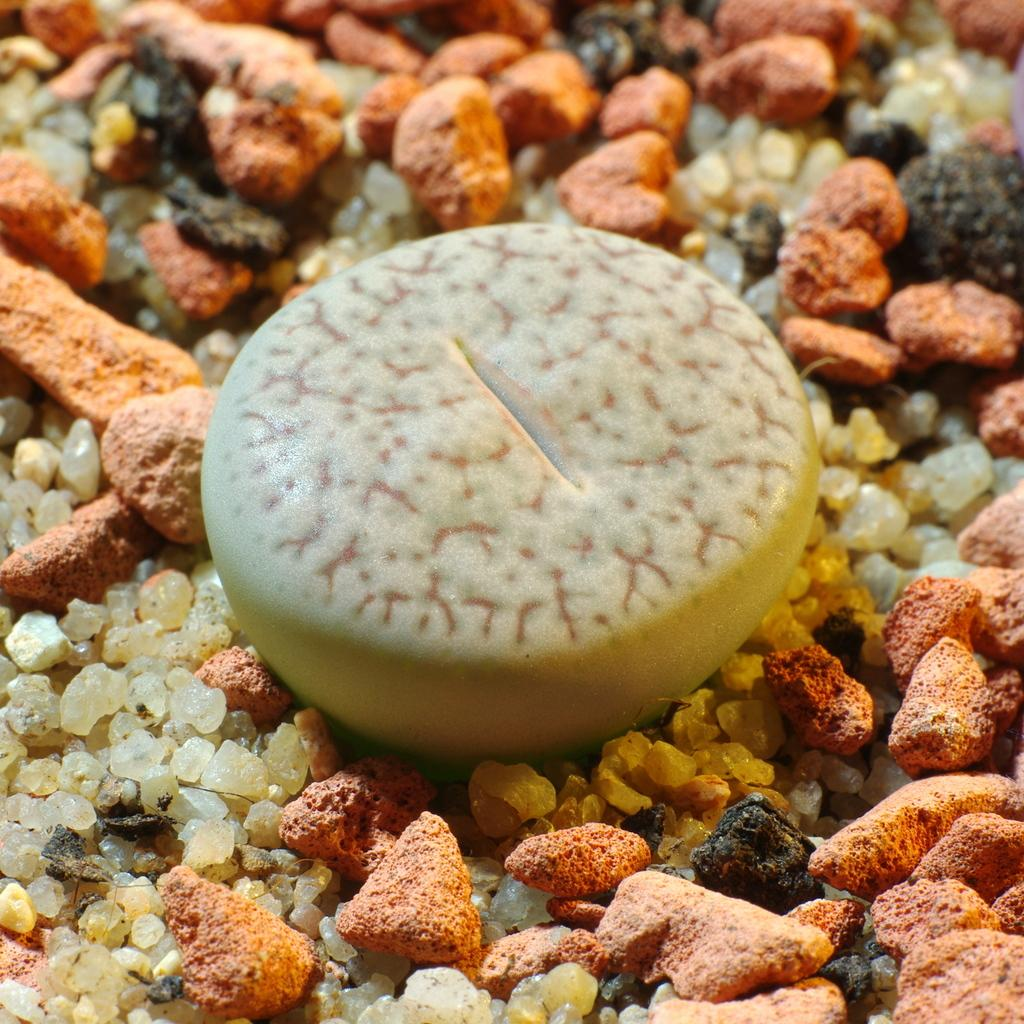What type of objects can be seen in the image? There are stones in the image. What is the manager's favorite spot in the image? There is no mention of a manager or a favorite spot in the image, as it only features stones. 